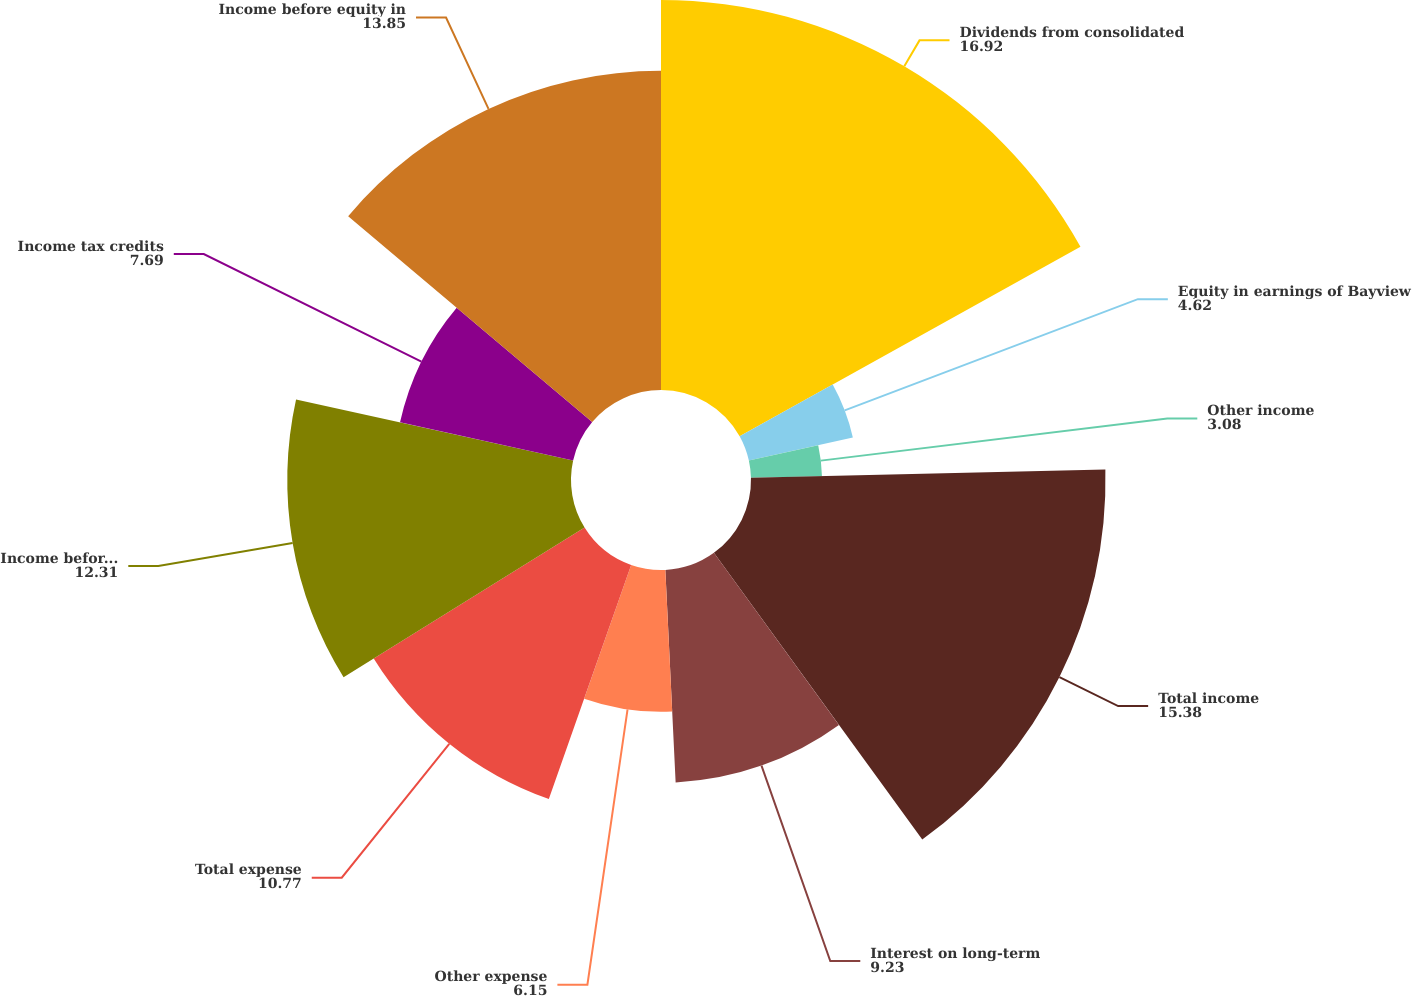Convert chart. <chart><loc_0><loc_0><loc_500><loc_500><pie_chart><fcel>Dividends from consolidated<fcel>Equity in earnings of Bayview<fcel>Other income<fcel>Total income<fcel>Interest on long-term<fcel>Other expense<fcel>Total expense<fcel>Income before income taxes and<fcel>Income tax credits<fcel>Income before equity in<nl><fcel>16.92%<fcel>4.62%<fcel>3.08%<fcel>15.38%<fcel>9.23%<fcel>6.15%<fcel>10.77%<fcel>12.31%<fcel>7.69%<fcel>13.85%<nl></chart> 